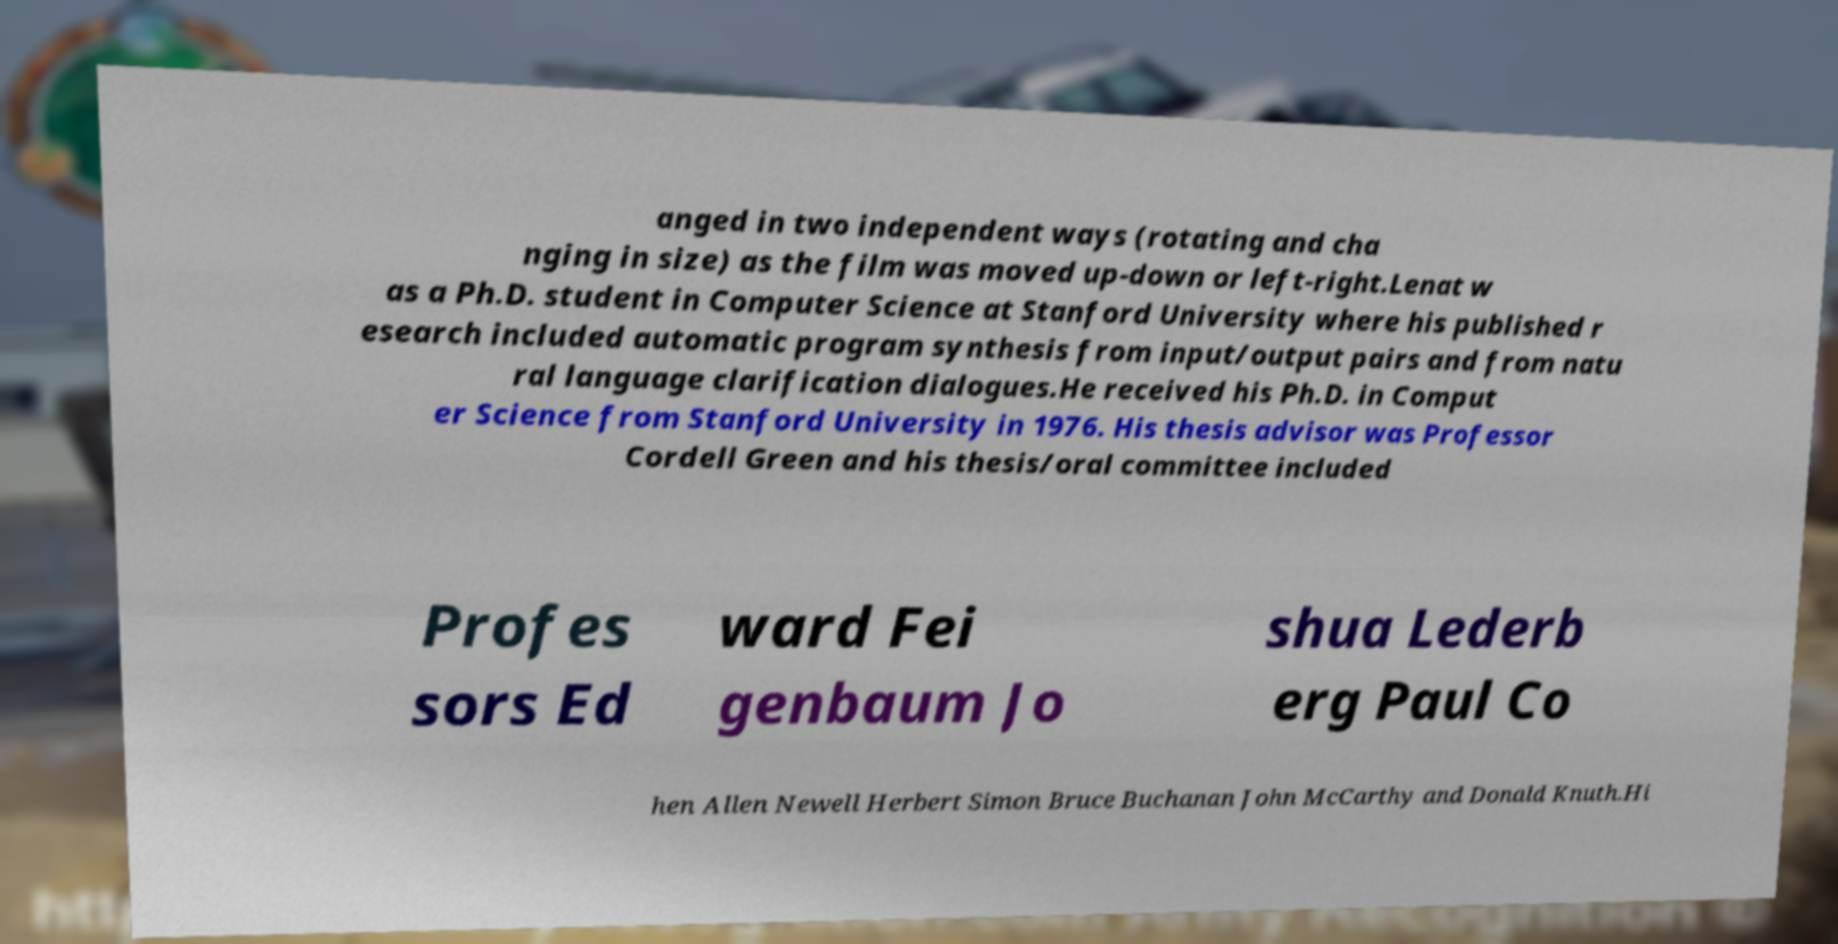Can you read and provide the text displayed in the image?This photo seems to have some interesting text. Can you extract and type it out for me? anged in two independent ways (rotating and cha nging in size) as the film was moved up-down or left-right.Lenat w as a Ph.D. student in Computer Science at Stanford University where his published r esearch included automatic program synthesis from input/output pairs and from natu ral language clarification dialogues.He received his Ph.D. in Comput er Science from Stanford University in 1976. His thesis advisor was Professor Cordell Green and his thesis/oral committee included Profes sors Ed ward Fei genbaum Jo shua Lederb erg Paul Co hen Allen Newell Herbert Simon Bruce Buchanan John McCarthy and Donald Knuth.Hi 